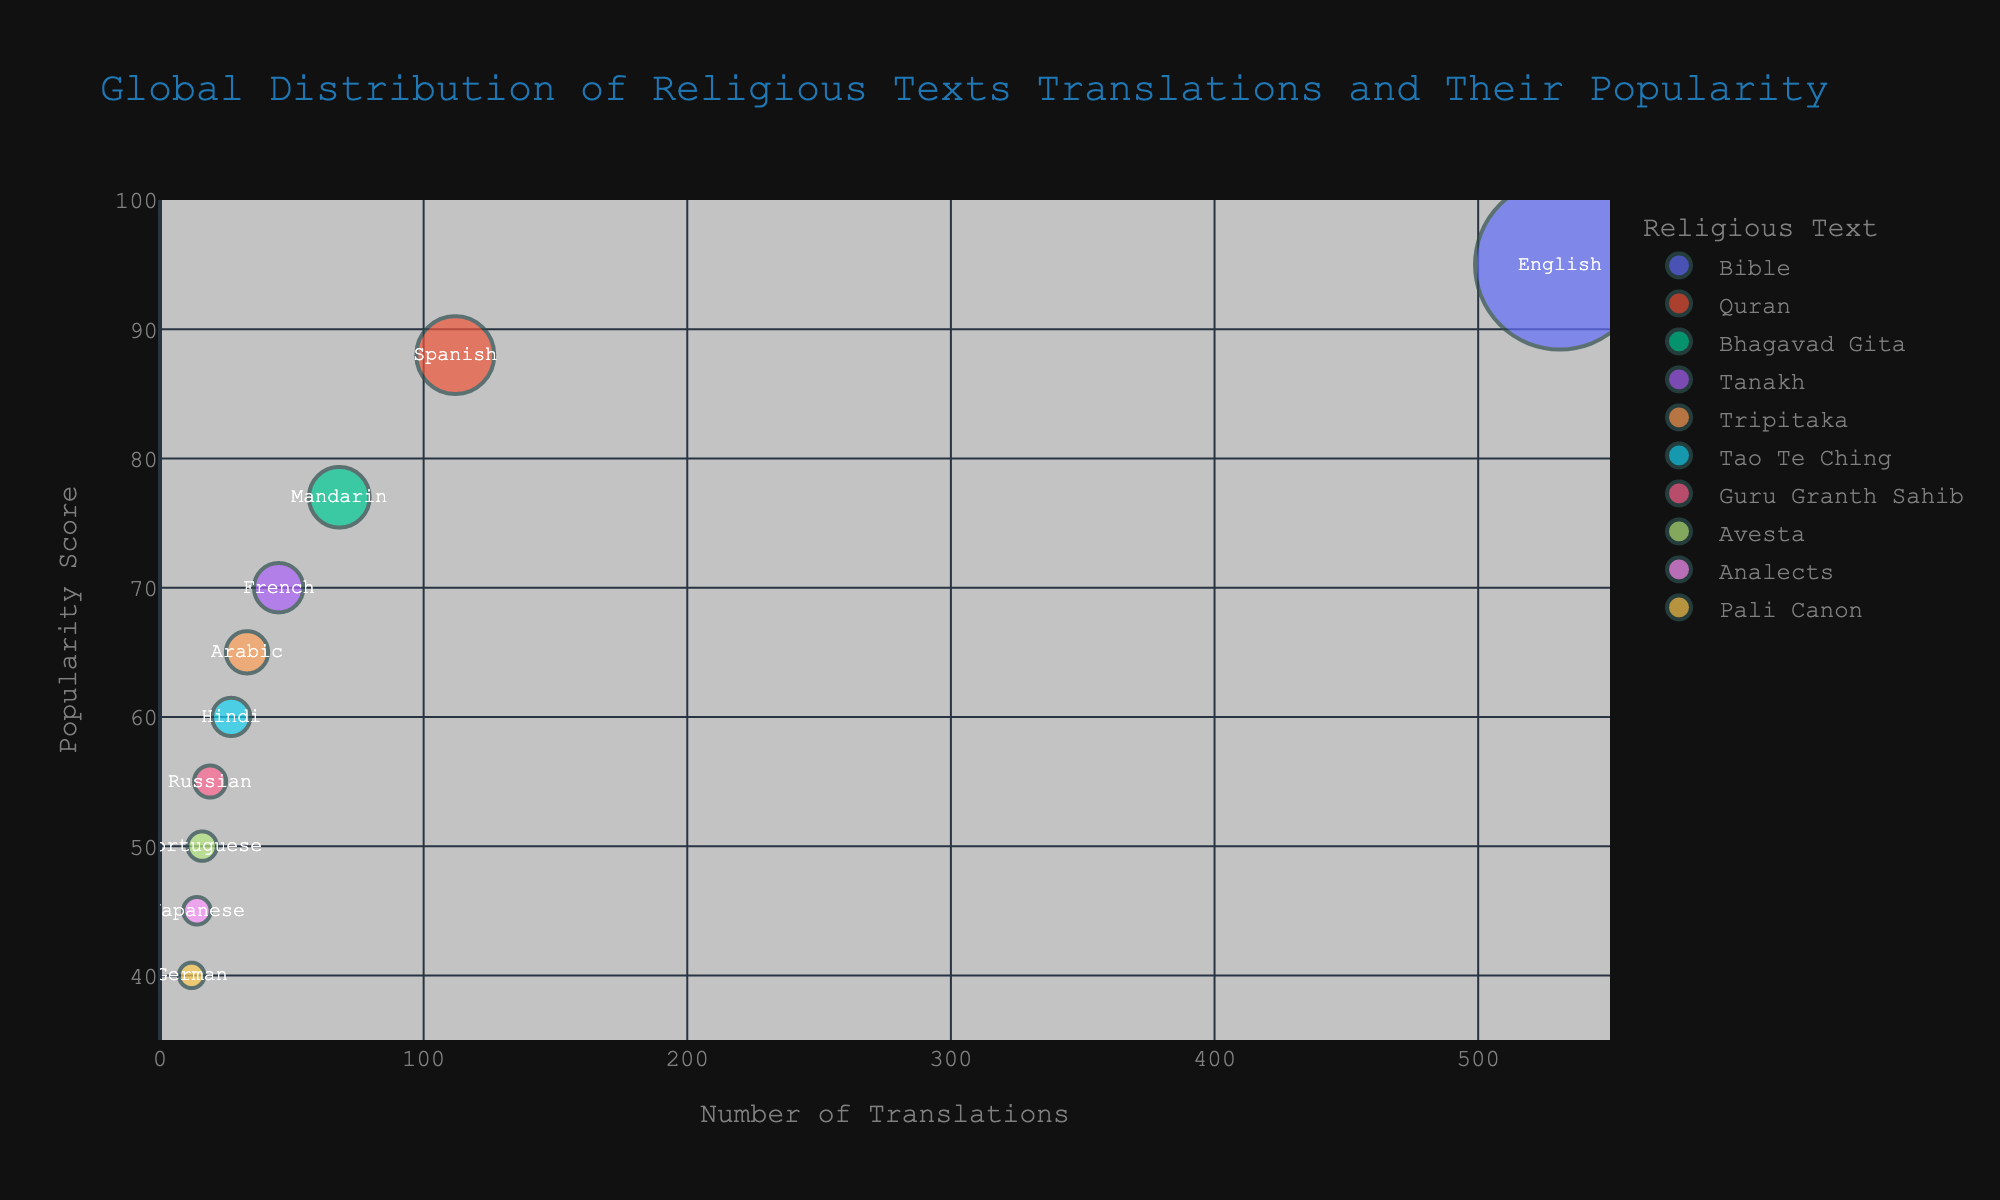How many languages have translations of religious texts in the chart? To determine the number of languages, we look at the data points which represent texts translated into different languages. Each bubble on the chart represents one language.
Answer: 10 Which religious text is shown to have the highest popularity score? The popularity score is represented on the y-axis. The bubble closest to the top of the chart indicates the highest popularity score.
Answer: Bible What is the number of translations for the religious text "Analects"? To find this, we locate the bubble for the "Analects" and check its position along the x-axis which represents the number of translations.
Answer: 14 Which language has translations with a popularity score of 45? By locating the position 45 on the y-axis and finding the corresponding bubble at that height, we can identify the language.
Answer: Japanese Between the Bible and the Bhagavad Gita, which one has more translations, and by how much? To compare translations, we look at the x-axis values for both texts. The Bible has 531 translations, and the Bhagavad Gita has 68. The difference is calculated by subtracting 68 from 531.
Answer: 463 What is the approximate average number of translations for the texts with a popularity score greater than 70? Identify the bubbles with a popularity score greater than 70 from their positions on the y-axis: Bible (531), Quran (112), Bhagavad Gita (68). Sum these values: 531 + 112 + 68 = 711. Divide by the number of texts: 711/3.
Answer: 237 Which religious text has the lowest number of translations, and what is that number? To find the bubble closest to the left on the x-axis which represents the number of translations, we can identify the text and its corresponding number.
Answer: Pali Canon, 12 How does the popularity score of the Quran compare to that of the Tanakh? Look at the positions of both texts on the y-axis. The Quran has a higher position than the Tanakh, indicating a higher popularity score.
Answer: Quran is more popular If the total number of translations for all texts is calculated, what would be the result? Sum all the x-axis values as they represent the number of translations for each text: 531 + 112 + 68 + 45 + 33 + 27 + 19 + 16 + 14 + 12.
Answer: 877 Which two languages have the closest number of translations, and what are those numbers? Compare the x-axis values and look for the closest two. The closest are Russian (19) and Portuguese (16) with a difference of 3.
Answer: Russian and Portuguese, 19 and 16 